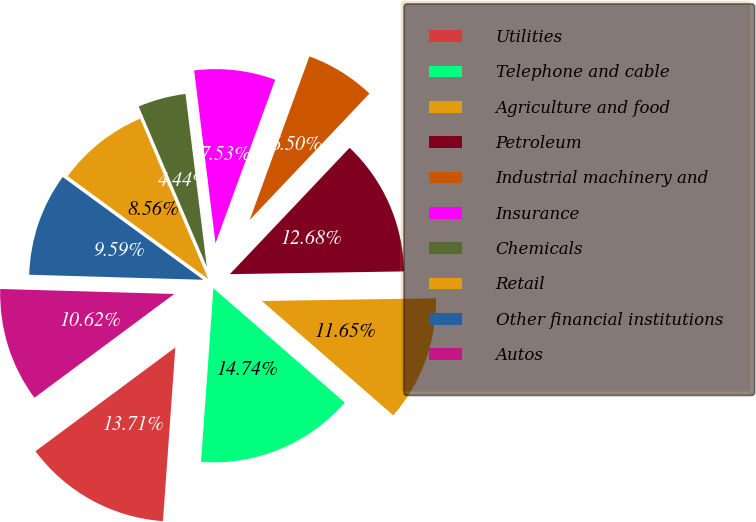<chart> <loc_0><loc_0><loc_500><loc_500><pie_chart><fcel>Utilities<fcel>Telephone and cable<fcel>Agriculture and food<fcel>Petroleum<fcel>Industrial machinery and<fcel>Insurance<fcel>Chemicals<fcel>Retail<fcel>Other financial institutions<fcel>Autos<nl><fcel>13.71%<fcel>14.74%<fcel>11.65%<fcel>12.68%<fcel>6.5%<fcel>7.53%<fcel>4.44%<fcel>8.56%<fcel>9.59%<fcel>10.62%<nl></chart> 